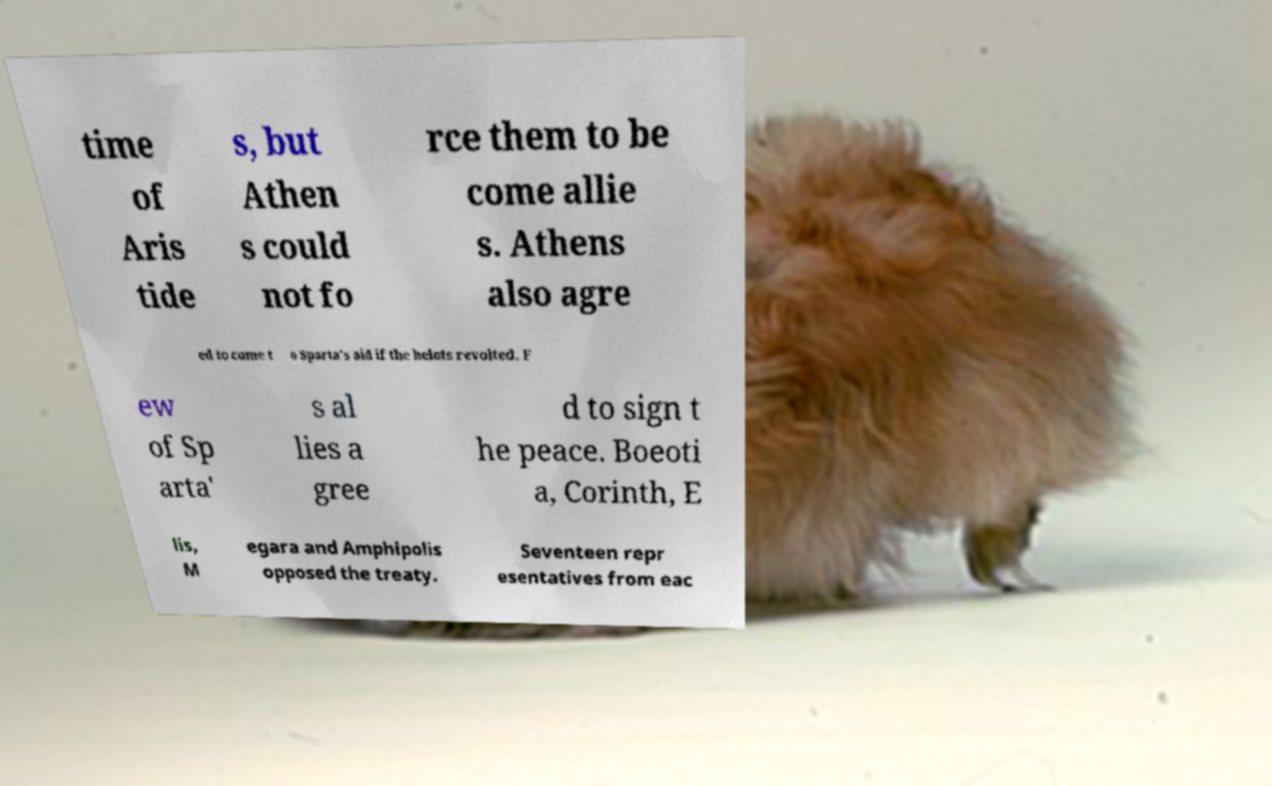Please read and relay the text visible in this image. What does it say? time of Aris tide s, but Athen s could not fo rce them to be come allie s. Athens also agre ed to come t o Sparta's aid if the helots revolted. F ew of Sp arta' s al lies a gree d to sign t he peace. Boeoti a, Corinth, E lis, M egara and Amphipolis opposed the treaty. Seventeen repr esentatives from eac 